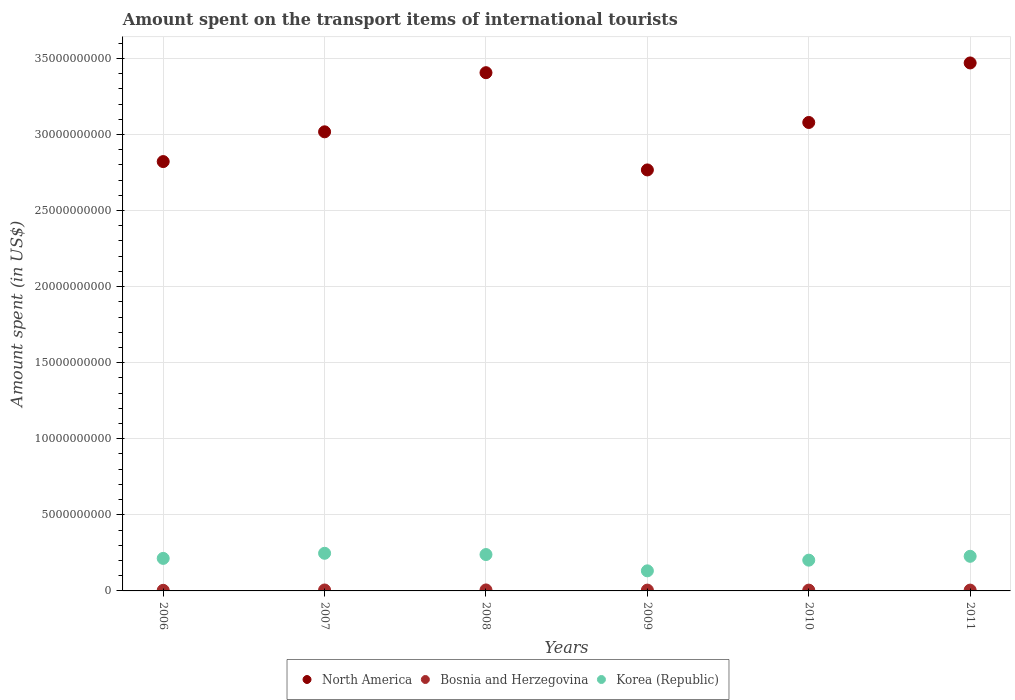Is the number of dotlines equal to the number of legend labels?
Provide a short and direct response. Yes. What is the amount spent on the transport items of international tourists in North America in 2010?
Ensure brevity in your answer.  3.08e+1. Across all years, what is the maximum amount spent on the transport items of international tourists in Korea (Republic)?
Give a very brief answer. 2.47e+09. Across all years, what is the minimum amount spent on the transport items of international tourists in North America?
Your answer should be very brief. 2.77e+1. In which year was the amount spent on the transport items of international tourists in North America maximum?
Provide a succinct answer. 2011. In which year was the amount spent on the transport items of international tourists in Bosnia and Herzegovina minimum?
Ensure brevity in your answer.  2006. What is the total amount spent on the transport items of international tourists in Korea (Republic) in the graph?
Your answer should be very brief. 1.26e+1. What is the difference between the amount spent on the transport items of international tourists in North America in 2008 and that in 2009?
Provide a short and direct response. 6.39e+09. What is the difference between the amount spent on the transport items of international tourists in Bosnia and Herzegovina in 2009 and the amount spent on the transport items of international tourists in North America in 2008?
Make the answer very short. -3.40e+1. What is the average amount spent on the transport items of international tourists in Korea (Republic) per year?
Offer a terse response. 2.10e+09. In the year 2008, what is the difference between the amount spent on the transport items of international tourists in North America and amount spent on the transport items of international tourists in Korea (Republic)?
Ensure brevity in your answer.  3.17e+1. In how many years, is the amount spent on the transport items of international tourists in Bosnia and Herzegovina greater than 18000000000 US$?
Provide a short and direct response. 0. What is the ratio of the amount spent on the transport items of international tourists in Korea (Republic) in 2007 to that in 2009?
Provide a succinct answer. 1.87. Is the amount spent on the transport items of international tourists in Korea (Republic) in 2006 less than that in 2010?
Your answer should be very brief. No. Is the difference between the amount spent on the transport items of international tourists in North America in 2008 and 2011 greater than the difference between the amount spent on the transport items of international tourists in Korea (Republic) in 2008 and 2011?
Give a very brief answer. No. What is the difference between the highest and the second highest amount spent on the transport items of international tourists in North America?
Offer a terse response. 6.41e+08. What is the difference between the highest and the lowest amount spent on the transport items of international tourists in Korea (Republic)?
Provide a succinct answer. 1.15e+09. In how many years, is the amount spent on the transport items of international tourists in Korea (Republic) greater than the average amount spent on the transport items of international tourists in Korea (Republic) taken over all years?
Provide a succinct answer. 4. Is the sum of the amount spent on the transport items of international tourists in Bosnia and Herzegovina in 2007 and 2010 greater than the maximum amount spent on the transport items of international tourists in North America across all years?
Ensure brevity in your answer.  No. Is it the case that in every year, the sum of the amount spent on the transport items of international tourists in Bosnia and Herzegovina and amount spent on the transport items of international tourists in Korea (Republic)  is greater than the amount spent on the transport items of international tourists in North America?
Keep it short and to the point. No. Is the amount spent on the transport items of international tourists in Bosnia and Herzegovina strictly greater than the amount spent on the transport items of international tourists in North America over the years?
Offer a terse response. No. Is the amount spent on the transport items of international tourists in Bosnia and Herzegovina strictly less than the amount spent on the transport items of international tourists in North America over the years?
Your response must be concise. Yes. How many years are there in the graph?
Keep it short and to the point. 6. What is the difference between two consecutive major ticks on the Y-axis?
Offer a terse response. 5.00e+09. Does the graph contain any zero values?
Provide a succinct answer. No. How are the legend labels stacked?
Offer a terse response. Horizontal. What is the title of the graph?
Offer a terse response. Amount spent on the transport items of international tourists. Does "Other small states" appear as one of the legend labels in the graph?
Provide a short and direct response. No. What is the label or title of the X-axis?
Your answer should be compact. Years. What is the label or title of the Y-axis?
Provide a succinct answer. Amount spent (in US$). What is the Amount spent (in US$) of North America in 2006?
Your response must be concise. 2.82e+1. What is the Amount spent (in US$) of Bosnia and Herzegovina in 2006?
Your answer should be compact. 4.00e+07. What is the Amount spent (in US$) in Korea (Republic) in 2006?
Provide a short and direct response. 2.14e+09. What is the Amount spent (in US$) of North America in 2007?
Give a very brief answer. 3.02e+1. What is the Amount spent (in US$) of Bosnia and Herzegovina in 2007?
Your answer should be very brief. 6.10e+07. What is the Amount spent (in US$) of Korea (Republic) in 2007?
Offer a terse response. 2.47e+09. What is the Amount spent (in US$) of North America in 2008?
Your answer should be very brief. 3.41e+1. What is the Amount spent (in US$) of Bosnia and Herzegovina in 2008?
Ensure brevity in your answer.  6.40e+07. What is the Amount spent (in US$) in Korea (Republic) in 2008?
Provide a short and direct response. 2.39e+09. What is the Amount spent (in US$) in North America in 2009?
Give a very brief answer. 2.77e+1. What is the Amount spent (in US$) of Bosnia and Herzegovina in 2009?
Give a very brief answer. 5.40e+07. What is the Amount spent (in US$) of Korea (Republic) in 2009?
Make the answer very short. 1.32e+09. What is the Amount spent (in US$) in North America in 2010?
Give a very brief answer. 3.08e+1. What is the Amount spent (in US$) of Bosnia and Herzegovina in 2010?
Make the answer very short. 5.30e+07. What is the Amount spent (in US$) in Korea (Republic) in 2010?
Make the answer very short. 2.02e+09. What is the Amount spent (in US$) of North America in 2011?
Your response must be concise. 3.47e+1. What is the Amount spent (in US$) of Bosnia and Herzegovina in 2011?
Offer a terse response. 5.40e+07. What is the Amount spent (in US$) in Korea (Republic) in 2011?
Your answer should be very brief. 2.28e+09. Across all years, what is the maximum Amount spent (in US$) in North America?
Your answer should be compact. 3.47e+1. Across all years, what is the maximum Amount spent (in US$) of Bosnia and Herzegovina?
Make the answer very short. 6.40e+07. Across all years, what is the maximum Amount spent (in US$) in Korea (Republic)?
Your response must be concise. 2.47e+09. Across all years, what is the minimum Amount spent (in US$) of North America?
Offer a terse response. 2.77e+1. Across all years, what is the minimum Amount spent (in US$) in Bosnia and Herzegovina?
Make the answer very short. 4.00e+07. Across all years, what is the minimum Amount spent (in US$) in Korea (Republic)?
Ensure brevity in your answer.  1.32e+09. What is the total Amount spent (in US$) of North America in the graph?
Your answer should be compact. 1.86e+11. What is the total Amount spent (in US$) in Bosnia and Herzegovina in the graph?
Make the answer very short. 3.26e+08. What is the total Amount spent (in US$) in Korea (Republic) in the graph?
Offer a terse response. 1.26e+1. What is the difference between the Amount spent (in US$) in North America in 2006 and that in 2007?
Provide a short and direct response. -1.96e+09. What is the difference between the Amount spent (in US$) of Bosnia and Herzegovina in 2006 and that in 2007?
Keep it short and to the point. -2.10e+07. What is the difference between the Amount spent (in US$) in Korea (Republic) in 2006 and that in 2007?
Offer a very short reply. -3.36e+08. What is the difference between the Amount spent (in US$) of North America in 2006 and that in 2008?
Your response must be concise. -5.84e+09. What is the difference between the Amount spent (in US$) in Bosnia and Herzegovina in 2006 and that in 2008?
Give a very brief answer. -2.40e+07. What is the difference between the Amount spent (in US$) of Korea (Republic) in 2006 and that in 2008?
Offer a very short reply. -2.53e+08. What is the difference between the Amount spent (in US$) in North America in 2006 and that in 2009?
Offer a very short reply. 5.49e+08. What is the difference between the Amount spent (in US$) of Bosnia and Herzegovina in 2006 and that in 2009?
Ensure brevity in your answer.  -1.40e+07. What is the difference between the Amount spent (in US$) of Korea (Republic) in 2006 and that in 2009?
Keep it short and to the point. 8.18e+08. What is the difference between the Amount spent (in US$) of North America in 2006 and that in 2010?
Your response must be concise. -2.57e+09. What is the difference between the Amount spent (in US$) of Bosnia and Herzegovina in 2006 and that in 2010?
Your answer should be very brief. -1.30e+07. What is the difference between the Amount spent (in US$) of Korea (Republic) in 2006 and that in 2010?
Make the answer very short. 1.16e+08. What is the difference between the Amount spent (in US$) of North America in 2006 and that in 2011?
Provide a short and direct response. -6.48e+09. What is the difference between the Amount spent (in US$) of Bosnia and Herzegovina in 2006 and that in 2011?
Give a very brief answer. -1.40e+07. What is the difference between the Amount spent (in US$) of Korea (Republic) in 2006 and that in 2011?
Your response must be concise. -1.37e+08. What is the difference between the Amount spent (in US$) in North America in 2007 and that in 2008?
Ensure brevity in your answer.  -3.89e+09. What is the difference between the Amount spent (in US$) in Bosnia and Herzegovina in 2007 and that in 2008?
Make the answer very short. -3.00e+06. What is the difference between the Amount spent (in US$) of Korea (Republic) in 2007 and that in 2008?
Offer a very short reply. 8.30e+07. What is the difference between the Amount spent (in US$) in North America in 2007 and that in 2009?
Your answer should be very brief. 2.50e+09. What is the difference between the Amount spent (in US$) in Korea (Republic) in 2007 and that in 2009?
Your answer should be compact. 1.15e+09. What is the difference between the Amount spent (in US$) in North America in 2007 and that in 2010?
Give a very brief answer. -6.14e+08. What is the difference between the Amount spent (in US$) of Bosnia and Herzegovina in 2007 and that in 2010?
Provide a short and direct response. 8.00e+06. What is the difference between the Amount spent (in US$) of Korea (Republic) in 2007 and that in 2010?
Your answer should be compact. 4.52e+08. What is the difference between the Amount spent (in US$) of North America in 2007 and that in 2011?
Offer a very short reply. -4.53e+09. What is the difference between the Amount spent (in US$) in Korea (Republic) in 2007 and that in 2011?
Make the answer very short. 1.99e+08. What is the difference between the Amount spent (in US$) in North America in 2008 and that in 2009?
Provide a short and direct response. 6.39e+09. What is the difference between the Amount spent (in US$) of Korea (Republic) in 2008 and that in 2009?
Provide a short and direct response. 1.07e+09. What is the difference between the Amount spent (in US$) in North America in 2008 and that in 2010?
Make the answer very short. 3.27e+09. What is the difference between the Amount spent (in US$) in Bosnia and Herzegovina in 2008 and that in 2010?
Provide a short and direct response. 1.10e+07. What is the difference between the Amount spent (in US$) of Korea (Republic) in 2008 and that in 2010?
Give a very brief answer. 3.69e+08. What is the difference between the Amount spent (in US$) of North America in 2008 and that in 2011?
Give a very brief answer. -6.41e+08. What is the difference between the Amount spent (in US$) in Bosnia and Herzegovina in 2008 and that in 2011?
Your response must be concise. 1.00e+07. What is the difference between the Amount spent (in US$) of Korea (Republic) in 2008 and that in 2011?
Offer a very short reply. 1.16e+08. What is the difference between the Amount spent (in US$) of North America in 2009 and that in 2010?
Offer a very short reply. -3.12e+09. What is the difference between the Amount spent (in US$) in Bosnia and Herzegovina in 2009 and that in 2010?
Your answer should be very brief. 1.00e+06. What is the difference between the Amount spent (in US$) of Korea (Republic) in 2009 and that in 2010?
Your answer should be compact. -7.02e+08. What is the difference between the Amount spent (in US$) of North America in 2009 and that in 2011?
Your answer should be very brief. -7.03e+09. What is the difference between the Amount spent (in US$) in Bosnia and Herzegovina in 2009 and that in 2011?
Provide a succinct answer. 0. What is the difference between the Amount spent (in US$) of Korea (Republic) in 2009 and that in 2011?
Make the answer very short. -9.55e+08. What is the difference between the Amount spent (in US$) of North America in 2010 and that in 2011?
Offer a very short reply. -3.91e+09. What is the difference between the Amount spent (in US$) of Bosnia and Herzegovina in 2010 and that in 2011?
Provide a short and direct response. -1.00e+06. What is the difference between the Amount spent (in US$) in Korea (Republic) in 2010 and that in 2011?
Keep it short and to the point. -2.53e+08. What is the difference between the Amount spent (in US$) of North America in 2006 and the Amount spent (in US$) of Bosnia and Herzegovina in 2007?
Ensure brevity in your answer.  2.82e+1. What is the difference between the Amount spent (in US$) of North America in 2006 and the Amount spent (in US$) of Korea (Republic) in 2007?
Offer a terse response. 2.57e+1. What is the difference between the Amount spent (in US$) of Bosnia and Herzegovina in 2006 and the Amount spent (in US$) of Korea (Republic) in 2007?
Your answer should be compact. -2.43e+09. What is the difference between the Amount spent (in US$) of North America in 2006 and the Amount spent (in US$) of Bosnia and Herzegovina in 2008?
Your response must be concise. 2.82e+1. What is the difference between the Amount spent (in US$) of North America in 2006 and the Amount spent (in US$) of Korea (Republic) in 2008?
Offer a terse response. 2.58e+1. What is the difference between the Amount spent (in US$) of Bosnia and Herzegovina in 2006 and the Amount spent (in US$) of Korea (Republic) in 2008?
Offer a terse response. -2.35e+09. What is the difference between the Amount spent (in US$) in North America in 2006 and the Amount spent (in US$) in Bosnia and Herzegovina in 2009?
Your answer should be very brief. 2.82e+1. What is the difference between the Amount spent (in US$) of North America in 2006 and the Amount spent (in US$) of Korea (Republic) in 2009?
Offer a terse response. 2.69e+1. What is the difference between the Amount spent (in US$) of Bosnia and Herzegovina in 2006 and the Amount spent (in US$) of Korea (Republic) in 2009?
Keep it short and to the point. -1.28e+09. What is the difference between the Amount spent (in US$) in North America in 2006 and the Amount spent (in US$) in Bosnia and Herzegovina in 2010?
Provide a succinct answer. 2.82e+1. What is the difference between the Amount spent (in US$) of North America in 2006 and the Amount spent (in US$) of Korea (Republic) in 2010?
Provide a short and direct response. 2.62e+1. What is the difference between the Amount spent (in US$) of Bosnia and Herzegovina in 2006 and the Amount spent (in US$) of Korea (Republic) in 2010?
Your response must be concise. -1.98e+09. What is the difference between the Amount spent (in US$) in North America in 2006 and the Amount spent (in US$) in Bosnia and Herzegovina in 2011?
Keep it short and to the point. 2.82e+1. What is the difference between the Amount spent (in US$) in North America in 2006 and the Amount spent (in US$) in Korea (Republic) in 2011?
Your response must be concise. 2.59e+1. What is the difference between the Amount spent (in US$) of Bosnia and Herzegovina in 2006 and the Amount spent (in US$) of Korea (Republic) in 2011?
Your answer should be very brief. -2.24e+09. What is the difference between the Amount spent (in US$) of North America in 2007 and the Amount spent (in US$) of Bosnia and Herzegovina in 2008?
Offer a very short reply. 3.01e+1. What is the difference between the Amount spent (in US$) of North America in 2007 and the Amount spent (in US$) of Korea (Republic) in 2008?
Keep it short and to the point. 2.78e+1. What is the difference between the Amount spent (in US$) of Bosnia and Herzegovina in 2007 and the Amount spent (in US$) of Korea (Republic) in 2008?
Your response must be concise. -2.33e+09. What is the difference between the Amount spent (in US$) in North America in 2007 and the Amount spent (in US$) in Bosnia and Herzegovina in 2009?
Your answer should be compact. 3.01e+1. What is the difference between the Amount spent (in US$) of North America in 2007 and the Amount spent (in US$) of Korea (Republic) in 2009?
Provide a short and direct response. 2.89e+1. What is the difference between the Amount spent (in US$) of Bosnia and Herzegovina in 2007 and the Amount spent (in US$) of Korea (Republic) in 2009?
Provide a short and direct response. -1.26e+09. What is the difference between the Amount spent (in US$) in North America in 2007 and the Amount spent (in US$) in Bosnia and Herzegovina in 2010?
Make the answer very short. 3.01e+1. What is the difference between the Amount spent (in US$) of North America in 2007 and the Amount spent (in US$) of Korea (Republic) in 2010?
Keep it short and to the point. 2.82e+1. What is the difference between the Amount spent (in US$) in Bosnia and Herzegovina in 2007 and the Amount spent (in US$) in Korea (Republic) in 2010?
Keep it short and to the point. -1.96e+09. What is the difference between the Amount spent (in US$) in North America in 2007 and the Amount spent (in US$) in Bosnia and Herzegovina in 2011?
Make the answer very short. 3.01e+1. What is the difference between the Amount spent (in US$) of North America in 2007 and the Amount spent (in US$) of Korea (Republic) in 2011?
Make the answer very short. 2.79e+1. What is the difference between the Amount spent (in US$) of Bosnia and Herzegovina in 2007 and the Amount spent (in US$) of Korea (Republic) in 2011?
Ensure brevity in your answer.  -2.21e+09. What is the difference between the Amount spent (in US$) of North America in 2008 and the Amount spent (in US$) of Bosnia and Herzegovina in 2009?
Your answer should be very brief. 3.40e+1. What is the difference between the Amount spent (in US$) in North America in 2008 and the Amount spent (in US$) in Korea (Republic) in 2009?
Keep it short and to the point. 3.27e+1. What is the difference between the Amount spent (in US$) of Bosnia and Herzegovina in 2008 and the Amount spent (in US$) of Korea (Republic) in 2009?
Offer a very short reply. -1.26e+09. What is the difference between the Amount spent (in US$) of North America in 2008 and the Amount spent (in US$) of Bosnia and Herzegovina in 2010?
Offer a terse response. 3.40e+1. What is the difference between the Amount spent (in US$) in North America in 2008 and the Amount spent (in US$) in Korea (Republic) in 2010?
Ensure brevity in your answer.  3.20e+1. What is the difference between the Amount spent (in US$) of Bosnia and Herzegovina in 2008 and the Amount spent (in US$) of Korea (Republic) in 2010?
Keep it short and to the point. -1.96e+09. What is the difference between the Amount spent (in US$) of North America in 2008 and the Amount spent (in US$) of Bosnia and Herzegovina in 2011?
Offer a very short reply. 3.40e+1. What is the difference between the Amount spent (in US$) in North America in 2008 and the Amount spent (in US$) in Korea (Republic) in 2011?
Offer a very short reply. 3.18e+1. What is the difference between the Amount spent (in US$) of Bosnia and Herzegovina in 2008 and the Amount spent (in US$) of Korea (Republic) in 2011?
Make the answer very short. -2.21e+09. What is the difference between the Amount spent (in US$) in North America in 2009 and the Amount spent (in US$) in Bosnia and Herzegovina in 2010?
Ensure brevity in your answer.  2.76e+1. What is the difference between the Amount spent (in US$) of North America in 2009 and the Amount spent (in US$) of Korea (Republic) in 2010?
Your answer should be very brief. 2.56e+1. What is the difference between the Amount spent (in US$) in Bosnia and Herzegovina in 2009 and the Amount spent (in US$) in Korea (Republic) in 2010?
Keep it short and to the point. -1.97e+09. What is the difference between the Amount spent (in US$) in North America in 2009 and the Amount spent (in US$) in Bosnia and Herzegovina in 2011?
Provide a succinct answer. 2.76e+1. What is the difference between the Amount spent (in US$) of North America in 2009 and the Amount spent (in US$) of Korea (Republic) in 2011?
Give a very brief answer. 2.54e+1. What is the difference between the Amount spent (in US$) in Bosnia and Herzegovina in 2009 and the Amount spent (in US$) in Korea (Republic) in 2011?
Your answer should be compact. -2.22e+09. What is the difference between the Amount spent (in US$) in North America in 2010 and the Amount spent (in US$) in Bosnia and Herzegovina in 2011?
Your answer should be very brief. 3.07e+1. What is the difference between the Amount spent (in US$) in North America in 2010 and the Amount spent (in US$) in Korea (Republic) in 2011?
Your answer should be very brief. 2.85e+1. What is the difference between the Amount spent (in US$) of Bosnia and Herzegovina in 2010 and the Amount spent (in US$) of Korea (Republic) in 2011?
Provide a short and direct response. -2.22e+09. What is the average Amount spent (in US$) of North America per year?
Give a very brief answer. 3.09e+1. What is the average Amount spent (in US$) of Bosnia and Herzegovina per year?
Your answer should be compact. 5.43e+07. What is the average Amount spent (in US$) of Korea (Republic) per year?
Give a very brief answer. 2.10e+09. In the year 2006, what is the difference between the Amount spent (in US$) of North America and Amount spent (in US$) of Bosnia and Herzegovina?
Ensure brevity in your answer.  2.82e+1. In the year 2006, what is the difference between the Amount spent (in US$) in North America and Amount spent (in US$) in Korea (Republic)?
Provide a short and direct response. 2.61e+1. In the year 2006, what is the difference between the Amount spent (in US$) in Bosnia and Herzegovina and Amount spent (in US$) in Korea (Republic)?
Ensure brevity in your answer.  -2.10e+09. In the year 2007, what is the difference between the Amount spent (in US$) of North America and Amount spent (in US$) of Bosnia and Herzegovina?
Offer a very short reply. 3.01e+1. In the year 2007, what is the difference between the Amount spent (in US$) of North America and Amount spent (in US$) of Korea (Republic)?
Keep it short and to the point. 2.77e+1. In the year 2007, what is the difference between the Amount spent (in US$) in Bosnia and Herzegovina and Amount spent (in US$) in Korea (Republic)?
Your response must be concise. -2.41e+09. In the year 2008, what is the difference between the Amount spent (in US$) of North America and Amount spent (in US$) of Bosnia and Herzegovina?
Provide a succinct answer. 3.40e+1. In the year 2008, what is the difference between the Amount spent (in US$) of North America and Amount spent (in US$) of Korea (Republic)?
Give a very brief answer. 3.17e+1. In the year 2008, what is the difference between the Amount spent (in US$) in Bosnia and Herzegovina and Amount spent (in US$) in Korea (Republic)?
Offer a very short reply. -2.33e+09. In the year 2009, what is the difference between the Amount spent (in US$) of North America and Amount spent (in US$) of Bosnia and Herzegovina?
Provide a succinct answer. 2.76e+1. In the year 2009, what is the difference between the Amount spent (in US$) of North America and Amount spent (in US$) of Korea (Republic)?
Provide a succinct answer. 2.64e+1. In the year 2009, what is the difference between the Amount spent (in US$) in Bosnia and Herzegovina and Amount spent (in US$) in Korea (Republic)?
Your answer should be very brief. -1.27e+09. In the year 2010, what is the difference between the Amount spent (in US$) of North America and Amount spent (in US$) of Bosnia and Herzegovina?
Offer a very short reply. 3.07e+1. In the year 2010, what is the difference between the Amount spent (in US$) in North America and Amount spent (in US$) in Korea (Republic)?
Offer a terse response. 2.88e+1. In the year 2010, what is the difference between the Amount spent (in US$) of Bosnia and Herzegovina and Amount spent (in US$) of Korea (Republic)?
Your answer should be very brief. -1.97e+09. In the year 2011, what is the difference between the Amount spent (in US$) of North America and Amount spent (in US$) of Bosnia and Herzegovina?
Provide a succinct answer. 3.46e+1. In the year 2011, what is the difference between the Amount spent (in US$) of North America and Amount spent (in US$) of Korea (Republic)?
Give a very brief answer. 3.24e+1. In the year 2011, what is the difference between the Amount spent (in US$) in Bosnia and Herzegovina and Amount spent (in US$) in Korea (Republic)?
Keep it short and to the point. -2.22e+09. What is the ratio of the Amount spent (in US$) of North America in 2006 to that in 2007?
Offer a terse response. 0.94. What is the ratio of the Amount spent (in US$) of Bosnia and Herzegovina in 2006 to that in 2007?
Provide a succinct answer. 0.66. What is the ratio of the Amount spent (in US$) in Korea (Republic) in 2006 to that in 2007?
Your answer should be compact. 0.86. What is the ratio of the Amount spent (in US$) in North America in 2006 to that in 2008?
Your response must be concise. 0.83. What is the ratio of the Amount spent (in US$) of Bosnia and Herzegovina in 2006 to that in 2008?
Provide a short and direct response. 0.62. What is the ratio of the Amount spent (in US$) in Korea (Republic) in 2006 to that in 2008?
Your answer should be compact. 0.89. What is the ratio of the Amount spent (in US$) in North America in 2006 to that in 2009?
Your response must be concise. 1.02. What is the ratio of the Amount spent (in US$) in Bosnia and Herzegovina in 2006 to that in 2009?
Your response must be concise. 0.74. What is the ratio of the Amount spent (in US$) in Korea (Republic) in 2006 to that in 2009?
Your answer should be very brief. 1.62. What is the ratio of the Amount spent (in US$) in North America in 2006 to that in 2010?
Your answer should be very brief. 0.92. What is the ratio of the Amount spent (in US$) of Bosnia and Herzegovina in 2006 to that in 2010?
Your response must be concise. 0.75. What is the ratio of the Amount spent (in US$) of Korea (Republic) in 2006 to that in 2010?
Your answer should be compact. 1.06. What is the ratio of the Amount spent (in US$) of North America in 2006 to that in 2011?
Ensure brevity in your answer.  0.81. What is the ratio of the Amount spent (in US$) in Bosnia and Herzegovina in 2006 to that in 2011?
Provide a succinct answer. 0.74. What is the ratio of the Amount spent (in US$) in Korea (Republic) in 2006 to that in 2011?
Your response must be concise. 0.94. What is the ratio of the Amount spent (in US$) of North America in 2007 to that in 2008?
Your answer should be very brief. 0.89. What is the ratio of the Amount spent (in US$) in Bosnia and Herzegovina in 2007 to that in 2008?
Ensure brevity in your answer.  0.95. What is the ratio of the Amount spent (in US$) in Korea (Republic) in 2007 to that in 2008?
Your answer should be very brief. 1.03. What is the ratio of the Amount spent (in US$) in North America in 2007 to that in 2009?
Offer a very short reply. 1.09. What is the ratio of the Amount spent (in US$) of Bosnia and Herzegovina in 2007 to that in 2009?
Give a very brief answer. 1.13. What is the ratio of the Amount spent (in US$) of Korea (Republic) in 2007 to that in 2009?
Make the answer very short. 1.87. What is the ratio of the Amount spent (in US$) of North America in 2007 to that in 2010?
Provide a short and direct response. 0.98. What is the ratio of the Amount spent (in US$) of Bosnia and Herzegovina in 2007 to that in 2010?
Keep it short and to the point. 1.15. What is the ratio of the Amount spent (in US$) of Korea (Republic) in 2007 to that in 2010?
Your answer should be compact. 1.22. What is the ratio of the Amount spent (in US$) in North America in 2007 to that in 2011?
Offer a very short reply. 0.87. What is the ratio of the Amount spent (in US$) of Bosnia and Herzegovina in 2007 to that in 2011?
Offer a terse response. 1.13. What is the ratio of the Amount spent (in US$) of Korea (Republic) in 2007 to that in 2011?
Offer a terse response. 1.09. What is the ratio of the Amount spent (in US$) in North America in 2008 to that in 2009?
Give a very brief answer. 1.23. What is the ratio of the Amount spent (in US$) in Bosnia and Herzegovina in 2008 to that in 2009?
Make the answer very short. 1.19. What is the ratio of the Amount spent (in US$) of Korea (Republic) in 2008 to that in 2009?
Offer a terse response. 1.81. What is the ratio of the Amount spent (in US$) in North America in 2008 to that in 2010?
Keep it short and to the point. 1.11. What is the ratio of the Amount spent (in US$) in Bosnia and Herzegovina in 2008 to that in 2010?
Your answer should be very brief. 1.21. What is the ratio of the Amount spent (in US$) of Korea (Republic) in 2008 to that in 2010?
Give a very brief answer. 1.18. What is the ratio of the Amount spent (in US$) of North America in 2008 to that in 2011?
Give a very brief answer. 0.98. What is the ratio of the Amount spent (in US$) of Bosnia and Herzegovina in 2008 to that in 2011?
Give a very brief answer. 1.19. What is the ratio of the Amount spent (in US$) of Korea (Republic) in 2008 to that in 2011?
Provide a succinct answer. 1.05. What is the ratio of the Amount spent (in US$) in North America in 2009 to that in 2010?
Keep it short and to the point. 0.9. What is the ratio of the Amount spent (in US$) of Bosnia and Herzegovina in 2009 to that in 2010?
Your answer should be compact. 1.02. What is the ratio of the Amount spent (in US$) in Korea (Republic) in 2009 to that in 2010?
Give a very brief answer. 0.65. What is the ratio of the Amount spent (in US$) in North America in 2009 to that in 2011?
Keep it short and to the point. 0.8. What is the ratio of the Amount spent (in US$) of Bosnia and Herzegovina in 2009 to that in 2011?
Offer a very short reply. 1. What is the ratio of the Amount spent (in US$) of Korea (Republic) in 2009 to that in 2011?
Give a very brief answer. 0.58. What is the ratio of the Amount spent (in US$) in North America in 2010 to that in 2011?
Your answer should be compact. 0.89. What is the ratio of the Amount spent (in US$) of Bosnia and Herzegovina in 2010 to that in 2011?
Your response must be concise. 0.98. What is the ratio of the Amount spent (in US$) of Korea (Republic) in 2010 to that in 2011?
Ensure brevity in your answer.  0.89. What is the difference between the highest and the second highest Amount spent (in US$) of North America?
Ensure brevity in your answer.  6.41e+08. What is the difference between the highest and the second highest Amount spent (in US$) in Bosnia and Herzegovina?
Your answer should be compact. 3.00e+06. What is the difference between the highest and the second highest Amount spent (in US$) in Korea (Republic)?
Ensure brevity in your answer.  8.30e+07. What is the difference between the highest and the lowest Amount spent (in US$) in North America?
Your answer should be compact. 7.03e+09. What is the difference between the highest and the lowest Amount spent (in US$) in Bosnia and Herzegovina?
Offer a terse response. 2.40e+07. What is the difference between the highest and the lowest Amount spent (in US$) of Korea (Republic)?
Offer a very short reply. 1.15e+09. 